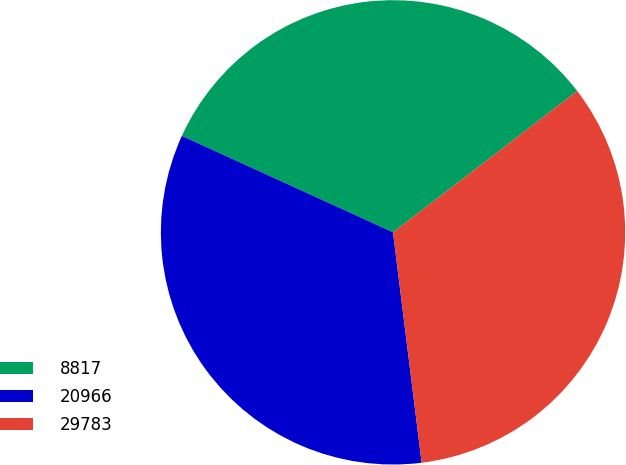Convert chart to OTSL. <chart><loc_0><loc_0><loc_500><loc_500><pie_chart><fcel>8817<fcel>20966<fcel>29783<nl><fcel>32.76%<fcel>33.79%<fcel>33.45%<nl></chart> 